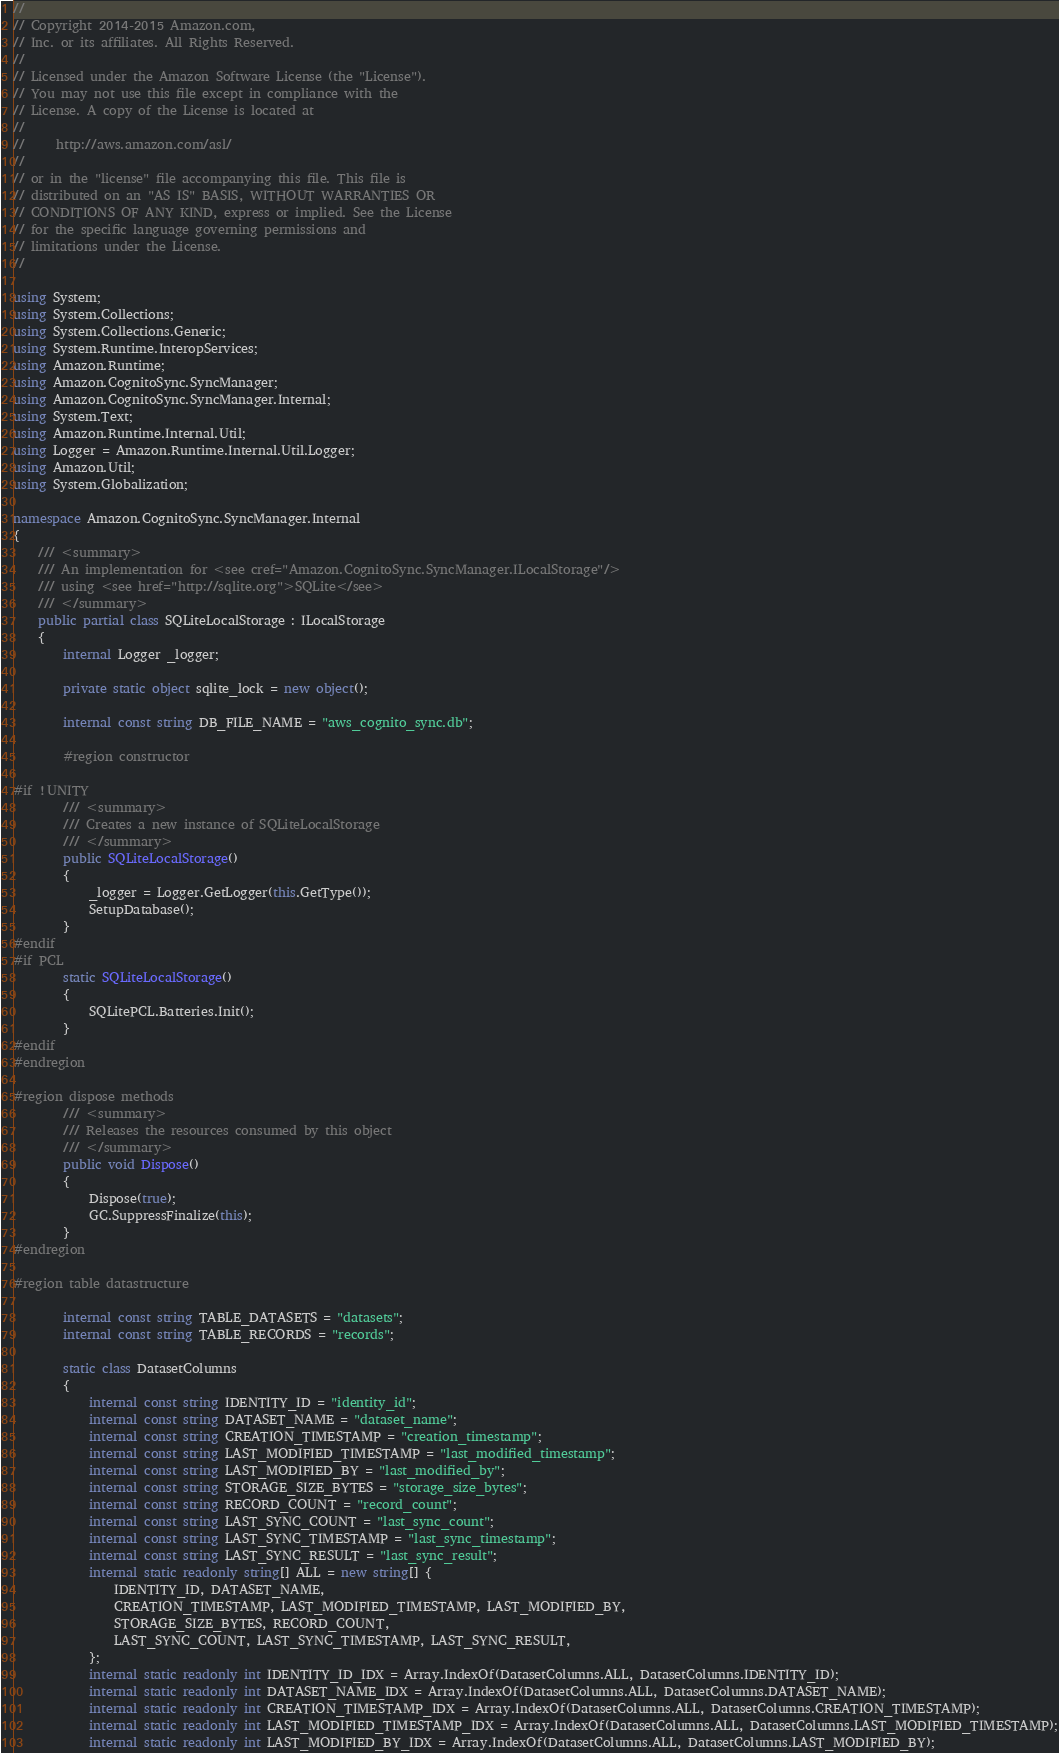Convert code to text. <code><loc_0><loc_0><loc_500><loc_500><_C#_>//
// Copyright 2014-2015 Amazon.com, 
// Inc. or its affiliates. All Rights Reserved.
// 
// Licensed under the Amazon Software License (the "License"). 
// You may not use this file except in compliance with the 
// License. A copy of the License is located at
// 
//     http://aws.amazon.com/asl/
// 
// or in the "license" file accompanying this file. This file is 
// distributed on an "AS IS" BASIS, WITHOUT WARRANTIES OR 
// CONDITIONS OF ANY KIND, express or implied. See the License 
// for the specific language governing permissions and 
// limitations under the License.
//

using System;
using System.Collections;
using System.Collections.Generic;
using System.Runtime.InteropServices;
using Amazon.Runtime;
using Amazon.CognitoSync.SyncManager;
using Amazon.CognitoSync.SyncManager.Internal;
using System.Text;
using Amazon.Runtime.Internal.Util;
using Logger = Amazon.Runtime.Internal.Util.Logger;
using Amazon.Util;
using System.Globalization;

namespace Amazon.CognitoSync.SyncManager.Internal
{
    /// <summary>
    /// An implementation for <see cref="Amazon.CognitoSync.SyncManager.ILocalStorage"/> 
    /// using <see href="http://sqlite.org">SQLite</see>
    /// </summary>
    public partial class SQLiteLocalStorage : ILocalStorage
    {
        internal Logger _logger;

        private static object sqlite_lock = new object();

        internal const string DB_FILE_NAME = "aws_cognito_sync.db";

        #region constructor

#if !UNITY
        /// <summary>
        /// Creates a new instance of SQLiteLocalStorage
        /// </summary>
        public SQLiteLocalStorage()
        {
            _logger = Logger.GetLogger(this.GetType());
            SetupDatabase();
        }
#endif
#if PCL
        static SQLiteLocalStorage()
        {
            SQLitePCL.Batteries.Init();
        }
#endif
#endregion

#region dispose methods
        /// <summary>
        /// Releases the resources consumed by this object
        /// </summary>
        public void Dispose()
        {
            Dispose(true);
            GC.SuppressFinalize(this);
        }
#endregion

#region table datastructure

        internal const string TABLE_DATASETS = "datasets";
        internal const string TABLE_RECORDS = "records";

        static class DatasetColumns
        {
            internal const string IDENTITY_ID = "identity_id";
            internal const string DATASET_NAME = "dataset_name";
            internal const string CREATION_TIMESTAMP = "creation_timestamp";
            internal const string LAST_MODIFIED_TIMESTAMP = "last_modified_timestamp";
            internal const string LAST_MODIFIED_BY = "last_modified_by";
            internal const string STORAGE_SIZE_BYTES = "storage_size_bytes";
            internal const string RECORD_COUNT = "record_count";
            internal const string LAST_SYNC_COUNT = "last_sync_count";
            internal const string LAST_SYNC_TIMESTAMP = "last_sync_timestamp";
            internal const string LAST_SYNC_RESULT = "last_sync_result";
            internal static readonly string[] ALL = new string[] {
                IDENTITY_ID, DATASET_NAME,
                CREATION_TIMESTAMP, LAST_MODIFIED_TIMESTAMP, LAST_MODIFIED_BY,
                STORAGE_SIZE_BYTES, RECORD_COUNT,
                LAST_SYNC_COUNT, LAST_SYNC_TIMESTAMP, LAST_SYNC_RESULT,
            };
            internal static readonly int IDENTITY_ID_IDX = Array.IndexOf(DatasetColumns.ALL, DatasetColumns.IDENTITY_ID);
            internal static readonly int DATASET_NAME_IDX = Array.IndexOf(DatasetColumns.ALL, DatasetColumns.DATASET_NAME);
            internal static readonly int CREATION_TIMESTAMP_IDX = Array.IndexOf(DatasetColumns.ALL, DatasetColumns.CREATION_TIMESTAMP);
            internal static readonly int LAST_MODIFIED_TIMESTAMP_IDX = Array.IndexOf(DatasetColumns.ALL, DatasetColumns.LAST_MODIFIED_TIMESTAMP);
            internal static readonly int LAST_MODIFIED_BY_IDX = Array.IndexOf(DatasetColumns.ALL, DatasetColumns.LAST_MODIFIED_BY);</code> 